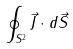Convert formula to latex. <formula><loc_0><loc_0><loc_500><loc_500>\oint _ { S ^ { 2 } } \vec { J } \cdot d \vec { S }</formula> 